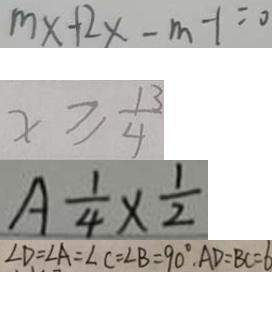Convert formula to latex. <formula><loc_0><loc_0><loc_500><loc_500>m x + 2 x - m - 1 = 0 
 x \geq \frac { 1 3 } { 4 } 
 A \frac { 1 } { 4 } \times \frac { 1 } { 2 } 
 \angle D = \angle A = \angle C = \angle B = 9 0 ^ { \circ } , A D = B C = 6</formula> 